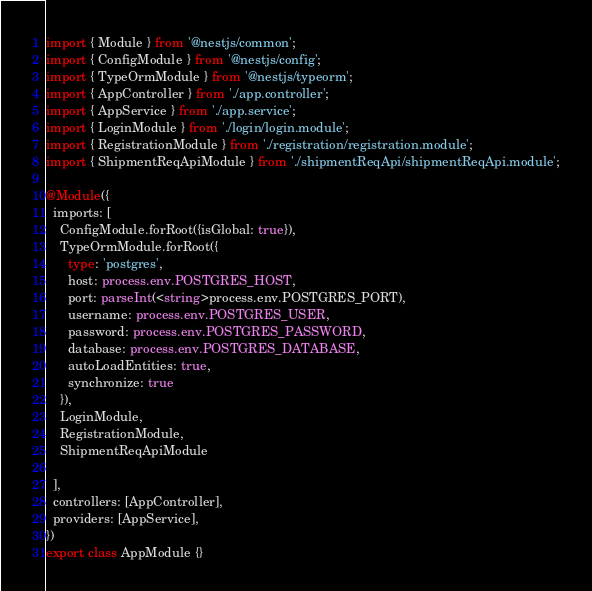Convert code to text. <code><loc_0><loc_0><loc_500><loc_500><_TypeScript_>import { Module } from '@nestjs/common';
import { ConfigModule } from '@nestjs/config'; 
import { TypeOrmModule } from '@nestjs/typeorm';
import { AppController } from './app.controller';
import { AppService } from './app.service';
import { LoginModule } from './login/login.module';
import { RegistrationModule } from './registration/registration.module';
import { ShipmentReqApiModule } from './shipmentReqApi/shipmentReqApi.module';

@Module({
  imports: [
    ConfigModule.forRoot({isGlobal: true}),
    TypeOrmModule.forRoot({
      type: 'postgres',
      host: process.env.POSTGRES_HOST,
      port: parseInt(<string>process.env.POSTGRES_PORT),
      username: process.env.POSTGRES_USER,
      password: process.env.POSTGRES_PASSWORD,
      database: process.env.POSTGRES_DATABASE,
      autoLoadEntities: true,
      synchronize: true
    }),
    LoginModule, 
    RegistrationModule, 
    ShipmentReqApiModule

  ],
  controllers: [AppController],
  providers: [AppService],
})
export class AppModule {}
</code> 